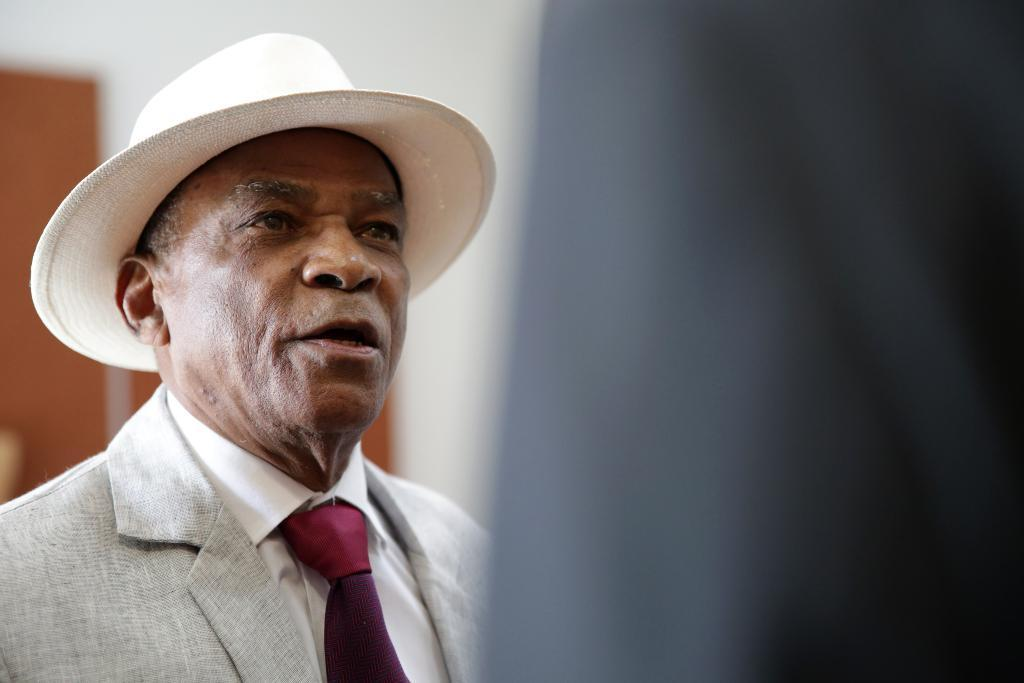Who is the main subject in the image? There is a man in the image. What is the man wearing? The man is wearing a cream-colored suit and a cowboy hat. Where is the man positioned in the image? The man is standing in the middle of the image. What type of powder is the man using to clean his apparel in the image? There is no powder or cleaning activity present in the image. 